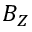<formula> <loc_0><loc_0><loc_500><loc_500>B _ { Z }</formula> 